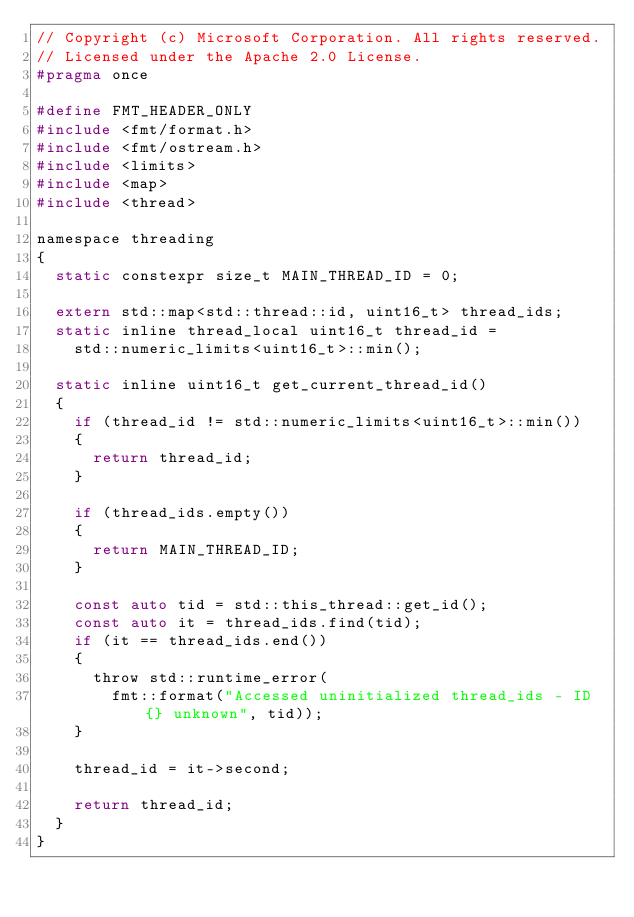<code> <loc_0><loc_0><loc_500><loc_500><_C_>// Copyright (c) Microsoft Corporation. All rights reserved.
// Licensed under the Apache 2.0 License.
#pragma once

#define FMT_HEADER_ONLY
#include <fmt/format.h>
#include <fmt/ostream.h>
#include <limits>
#include <map>
#include <thread>

namespace threading
{
  static constexpr size_t MAIN_THREAD_ID = 0;

  extern std::map<std::thread::id, uint16_t> thread_ids;
  static inline thread_local uint16_t thread_id =
    std::numeric_limits<uint16_t>::min();

  static inline uint16_t get_current_thread_id()
  {
    if (thread_id != std::numeric_limits<uint16_t>::min())
    {
      return thread_id;
    }

    if (thread_ids.empty())
    {
      return MAIN_THREAD_ID;
    }

    const auto tid = std::this_thread::get_id();
    const auto it = thread_ids.find(tid);
    if (it == thread_ids.end())
    {
      throw std::runtime_error(
        fmt::format("Accessed uninitialized thread_ids - ID {} unknown", tid));
    }

    thread_id = it->second;

    return thread_id;
  }
}</code> 